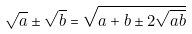<formula> <loc_0><loc_0><loc_500><loc_500>\sqrt { a } \pm \sqrt { b } = \sqrt { a + b \pm 2 \sqrt { a b } }</formula> 